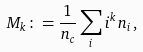<formula> <loc_0><loc_0><loc_500><loc_500>M _ { k } & \colon = \frac { 1 } { n _ { c } } \sum _ { i } { i ^ { k } n _ { i } } \, ,</formula> 